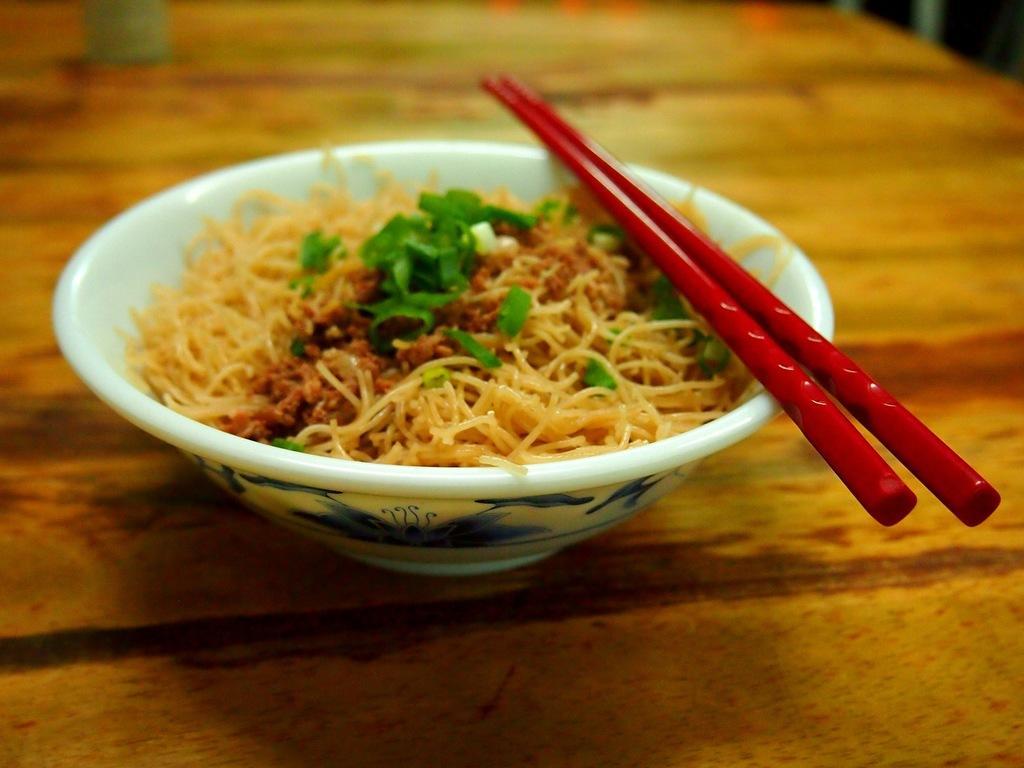Could you give a brief overview of what you see in this image? In this image there white bowl which is filled with food and there are red chop sticks above the bowl and this bowl is placed on the table. 